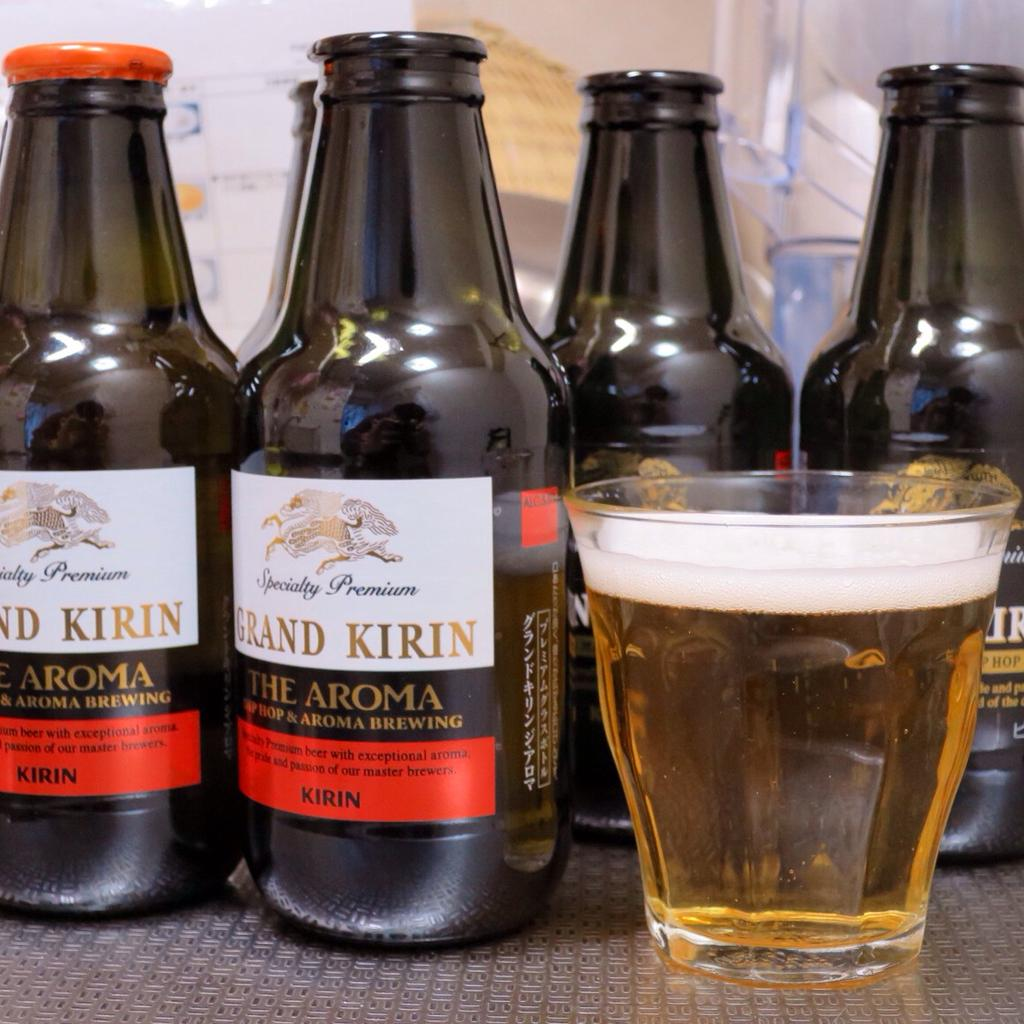<image>
Offer a succinct explanation of the picture presented. Four bottles of Grand Kirin beer and a small glass filled with the beer. 